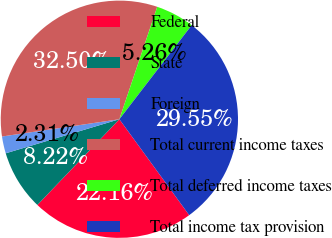Convert chart to OTSL. <chart><loc_0><loc_0><loc_500><loc_500><pie_chart><fcel>Federal<fcel>State<fcel>Foreign<fcel>Total current income taxes<fcel>Total deferred income taxes<fcel>Total income tax provision<nl><fcel>22.16%<fcel>8.22%<fcel>2.31%<fcel>32.5%<fcel>5.26%<fcel>29.55%<nl></chart> 